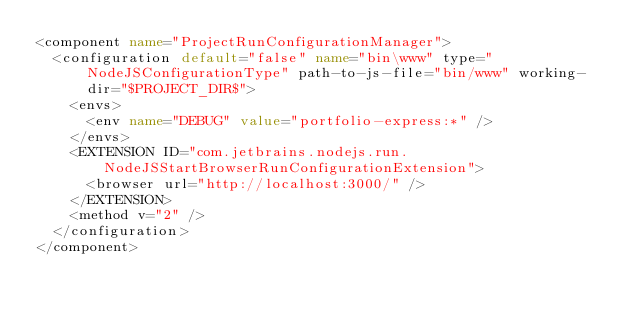Convert code to text. <code><loc_0><loc_0><loc_500><loc_500><_XML_><component name="ProjectRunConfigurationManager">
  <configuration default="false" name="bin\www" type="NodeJSConfigurationType" path-to-js-file="bin/www" working-dir="$PROJECT_DIR$">
    <envs>
      <env name="DEBUG" value="portfolio-express:*" />
    </envs>
    <EXTENSION ID="com.jetbrains.nodejs.run.NodeJSStartBrowserRunConfigurationExtension">
      <browser url="http://localhost:3000/" />
    </EXTENSION>
    <method v="2" />
  </configuration>
</component></code> 